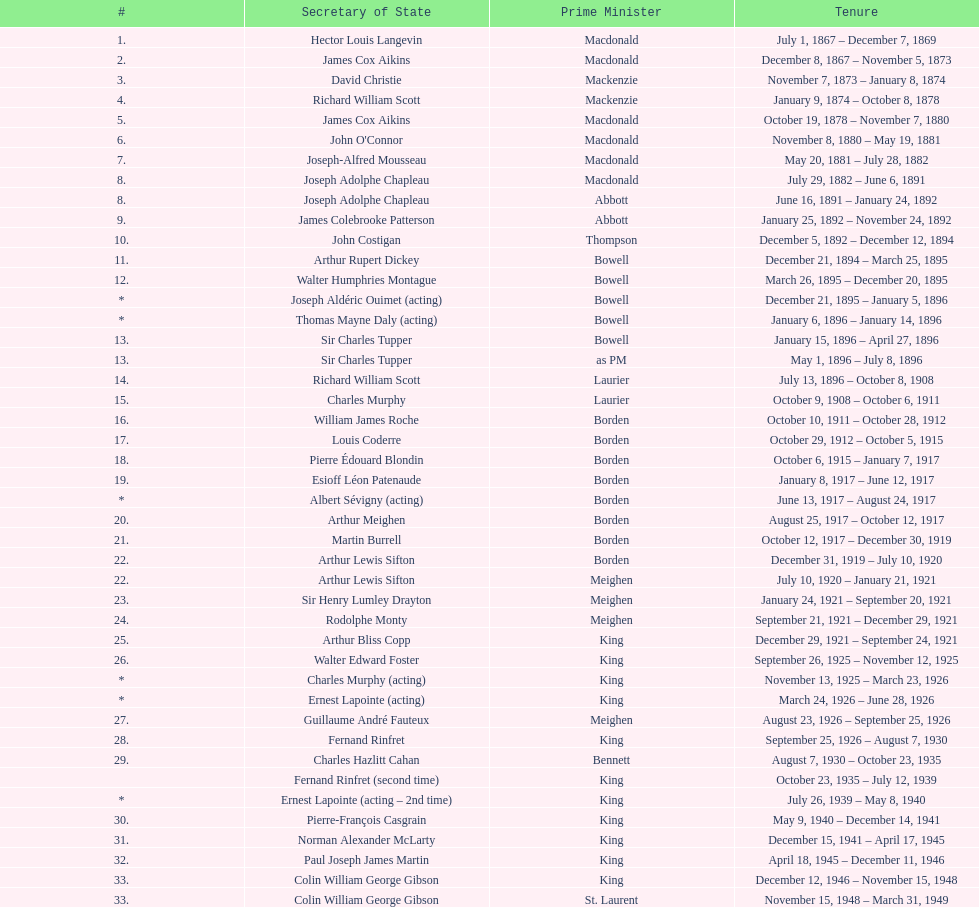After jack pickersgill, who served as the secretary of state? Roch Pinard. 